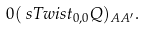Convert formula to latex. <formula><loc_0><loc_0><loc_500><loc_500>0 & ( \ s T w i s t _ { 0 , 0 } Q ) _ { A A ^ { \prime } } .</formula> 